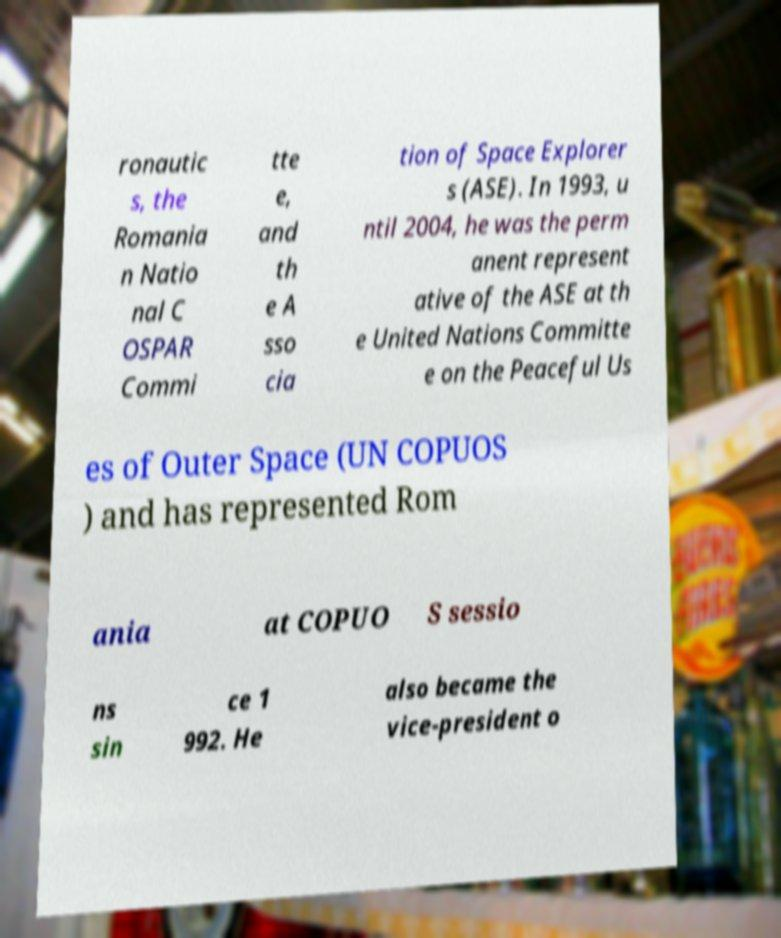Please read and relay the text visible in this image. What does it say? ronautic s, the Romania n Natio nal C OSPAR Commi tte e, and th e A sso cia tion of Space Explorer s (ASE). In 1993, u ntil 2004, he was the perm anent represent ative of the ASE at th e United Nations Committe e on the Peaceful Us es of Outer Space (UN COPUOS ) and has represented Rom ania at COPUO S sessio ns sin ce 1 992. He also became the vice-president o 